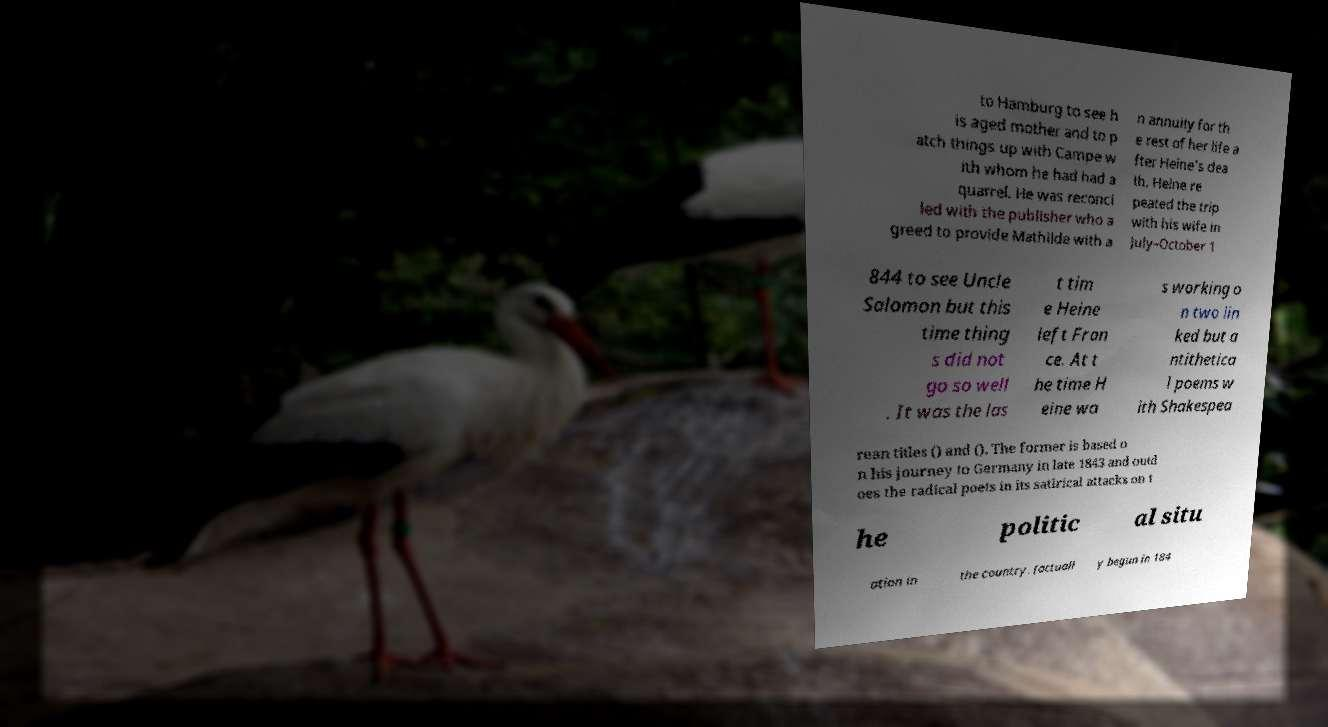What messages or text are displayed in this image? I need them in a readable, typed format. to Hamburg to see h is aged mother and to p atch things up with Campe w ith whom he had had a quarrel. He was reconci led with the publisher who a greed to provide Mathilde with a n annuity for th e rest of her life a fter Heine's dea th. Heine re peated the trip with his wife in July–October 1 844 to see Uncle Salomon but this time thing s did not go so well . It was the las t tim e Heine left Fran ce. At t he time H eine wa s working o n two lin ked but a ntithetica l poems w ith Shakespea rean titles () and (). The former is based o n his journey to Germany in late 1843 and outd oes the radical poets in its satirical attacks on t he politic al situ ation in the country. (actuall y begun in 184 